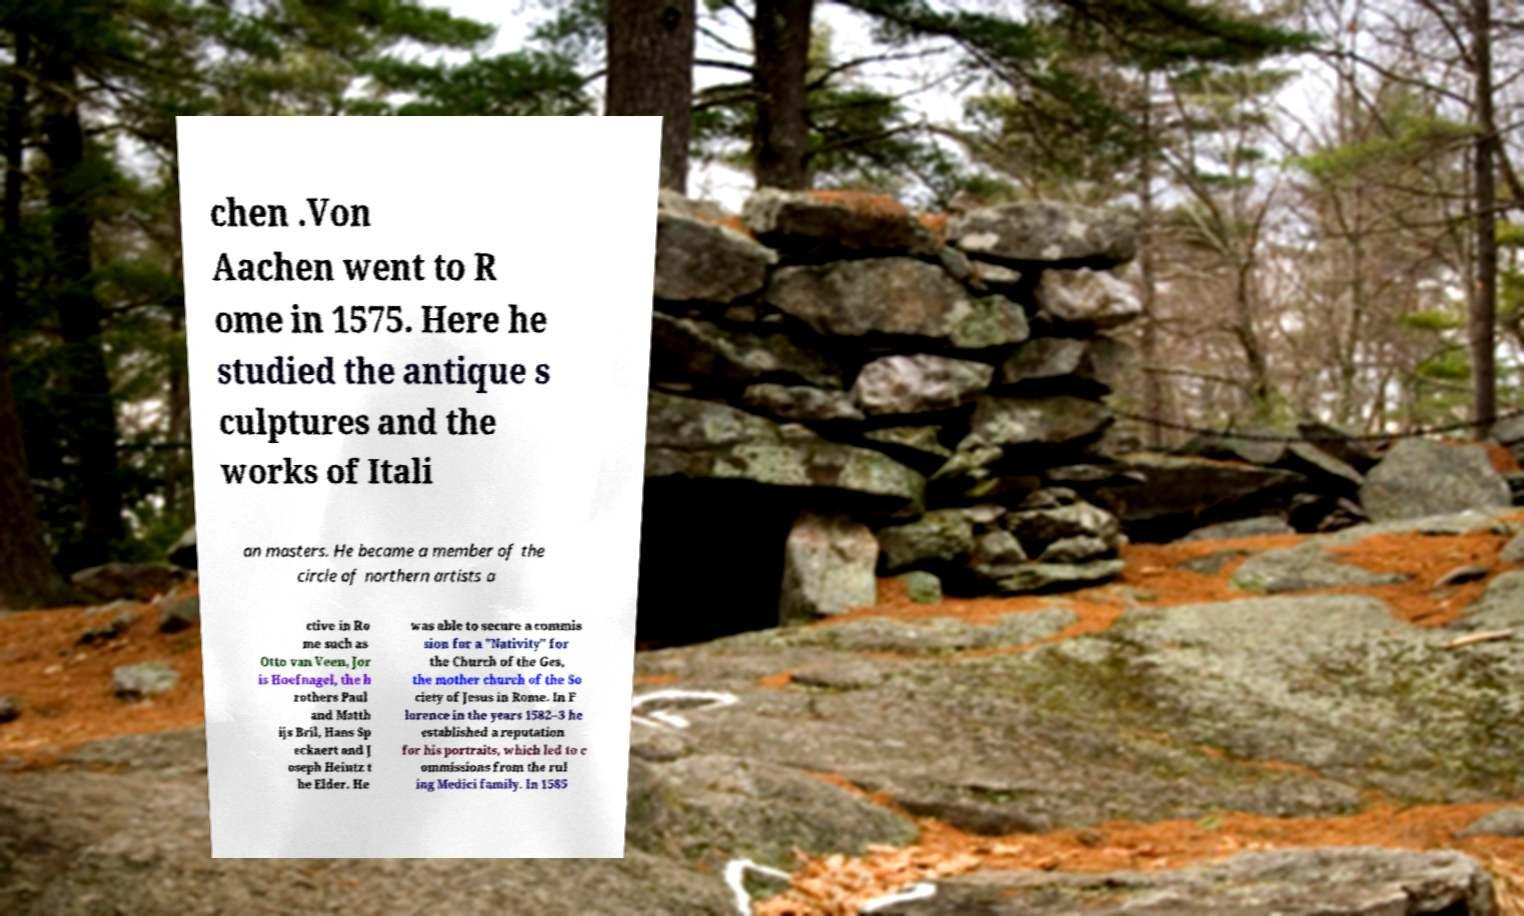There's text embedded in this image that I need extracted. Can you transcribe it verbatim? chen .Von Aachen went to R ome in 1575. Here he studied the antique s culptures and the works of Itali an masters. He became a member of the circle of northern artists a ctive in Ro me such as Otto van Veen, Jor is Hoefnagel, the b rothers Paul and Matth ijs Bril, Hans Sp eckaert and J oseph Heintz t he Elder. He was able to secure a commis sion for a "Nativity" for the Church of the Ges, the mother church of the So ciety of Jesus in Rome. In F lorence in the years 1582–3 he established a reputation for his portraits, which led to c ommissions from the rul ing Medici family. In 1585 